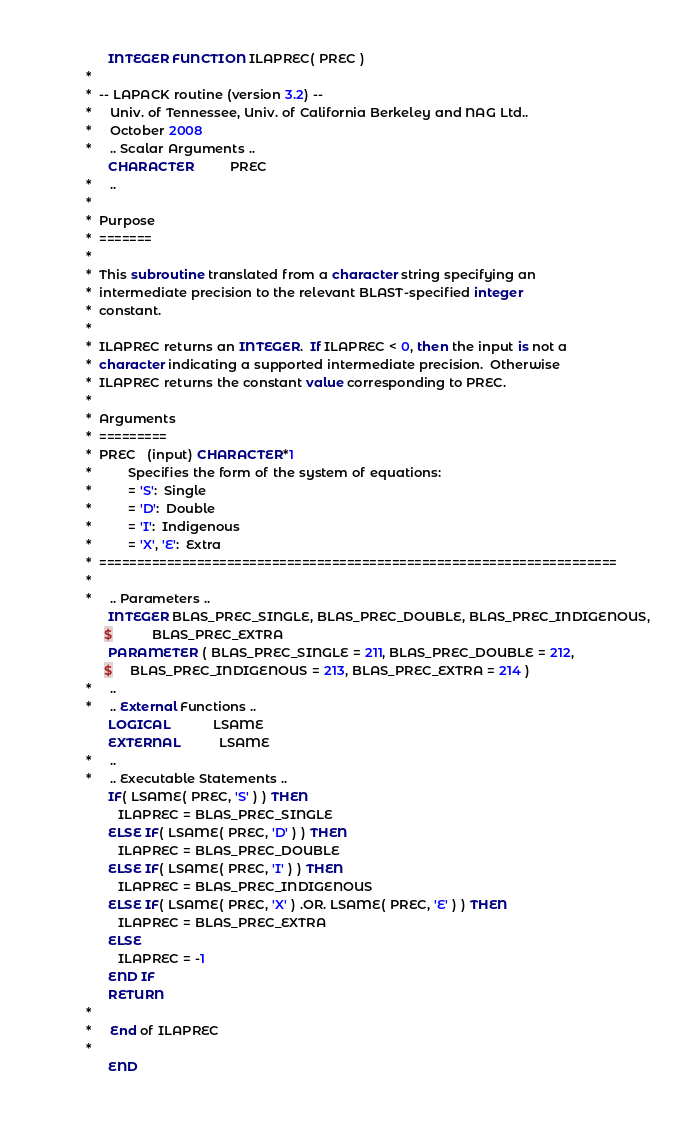<code> <loc_0><loc_0><loc_500><loc_500><_FORTRAN_>      INTEGER FUNCTION ILAPREC( PREC )
*
*  -- LAPACK routine (version 3.2) --
*     Univ. of Tennessee, Univ. of California Berkeley and NAG Ltd..
*     October 2008
*     .. Scalar Arguments ..
      CHARACTER          PREC
*     ..
*
*  Purpose
*  =======
*
*  This subroutine translated from a character string specifying an
*  intermediate precision to the relevant BLAST-specified integer
*  constant.
*
*  ILAPREC returns an INTEGER.  If ILAPREC < 0, then the input is not a
*  character indicating a supported intermediate precision.  Otherwise
*  ILAPREC returns the constant value corresponding to PREC.
*
*  Arguments
*  =========
*  PREC   (input) CHARACTER*1
*          Specifies the form of the system of equations:
*          = 'S':  Single
*          = 'D':  Double
*          = 'I':  Indigenous
*          = 'X', 'E':  Extra
*  =====================================================================
*
*     .. Parameters ..
      INTEGER BLAS_PREC_SINGLE, BLAS_PREC_DOUBLE, BLAS_PREC_INDIGENOUS,
     $           BLAS_PREC_EXTRA
      PARAMETER ( BLAS_PREC_SINGLE = 211, BLAS_PREC_DOUBLE = 212,
     $     BLAS_PREC_INDIGENOUS = 213, BLAS_PREC_EXTRA = 214 )
*     ..
*     .. External Functions ..
      LOGICAL            LSAME
      EXTERNAL           LSAME
*     ..
*     .. Executable Statements ..
      IF( LSAME( PREC, 'S' ) ) THEN
         ILAPREC = BLAS_PREC_SINGLE
      ELSE IF( LSAME( PREC, 'D' ) ) THEN
         ILAPREC = BLAS_PREC_DOUBLE
      ELSE IF( LSAME( PREC, 'I' ) ) THEN
         ILAPREC = BLAS_PREC_INDIGENOUS
      ELSE IF( LSAME( PREC, 'X' ) .OR. LSAME( PREC, 'E' ) ) THEN
         ILAPREC = BLAS_PREC_EXTRA
      ELSE
         ILAPREC = -1
      END IF
      RETURN
*
*     End of ILAPREC
*
      END
</code> 